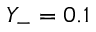<formula> <loc_0><loc_0><loc_500><loc_500>Y _ { - } = 0 . 1</formula> 